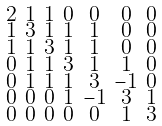<formula> <loc_0><loc_0><loc_500><loc_500>\begin{smallmatrix} 2 & 1 & 1 & 0 & 0 & 0 & 0 \\ 1 & 3 & 1 & 1 & 1 & 0 & 0 \\ 1 & 1 & 3 & 1 & 1 & 0 & 0 \\ 0 & 1 & 1 & 3 & 1 & 1 & 0 \\ 0 & 1 & 1 & 1 & 3 & - 1 & 0 \\ 0 & 0 & 0 & 1 & - 1 & 3 & 1 \\ 0 & 0 & 0 & 0 & 0 & 1 & 3 \end{smallmatrix}</formula> 